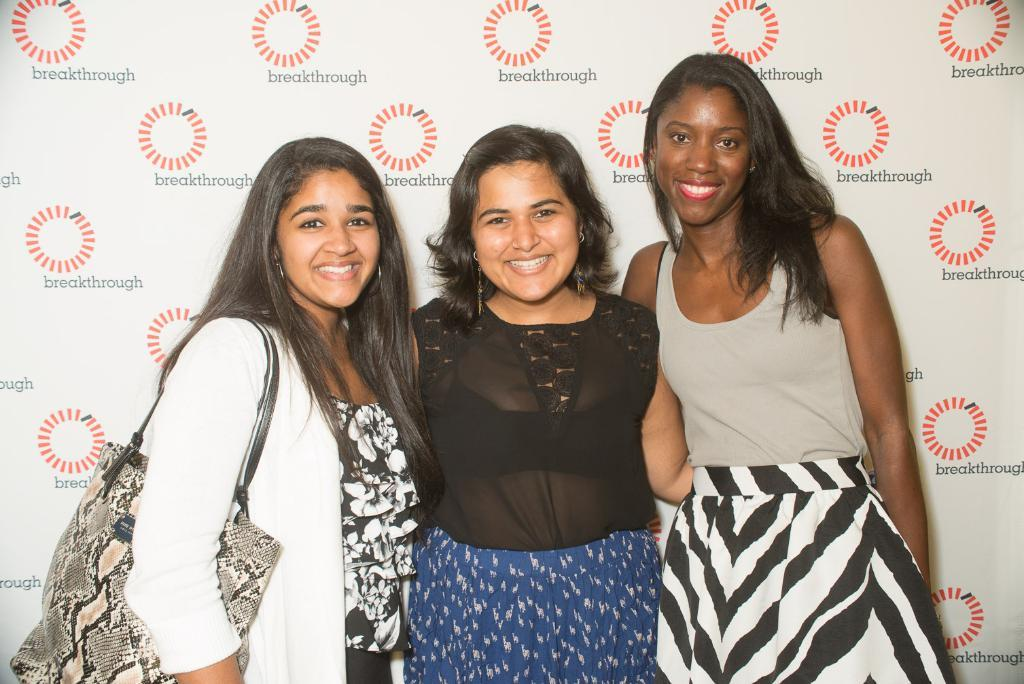How many ladies are present in the image? There are three ladies standing in the image. What is the lady on the left side holding? The lady on the left side is holding a bag. What can be seen in the background of the image? There is a wall with writing in the background of the image. Can you identify any logos in the image? Yes, there are logos visible in the image. What type of fan is being used by the lady on the right side of the image? There is no fan visible in the image; the ladies are not using any fans. What type of trade is being conducted by the ladies in the image? There is no indication of any trade being conducted in the image; the ladies are simply standing. 